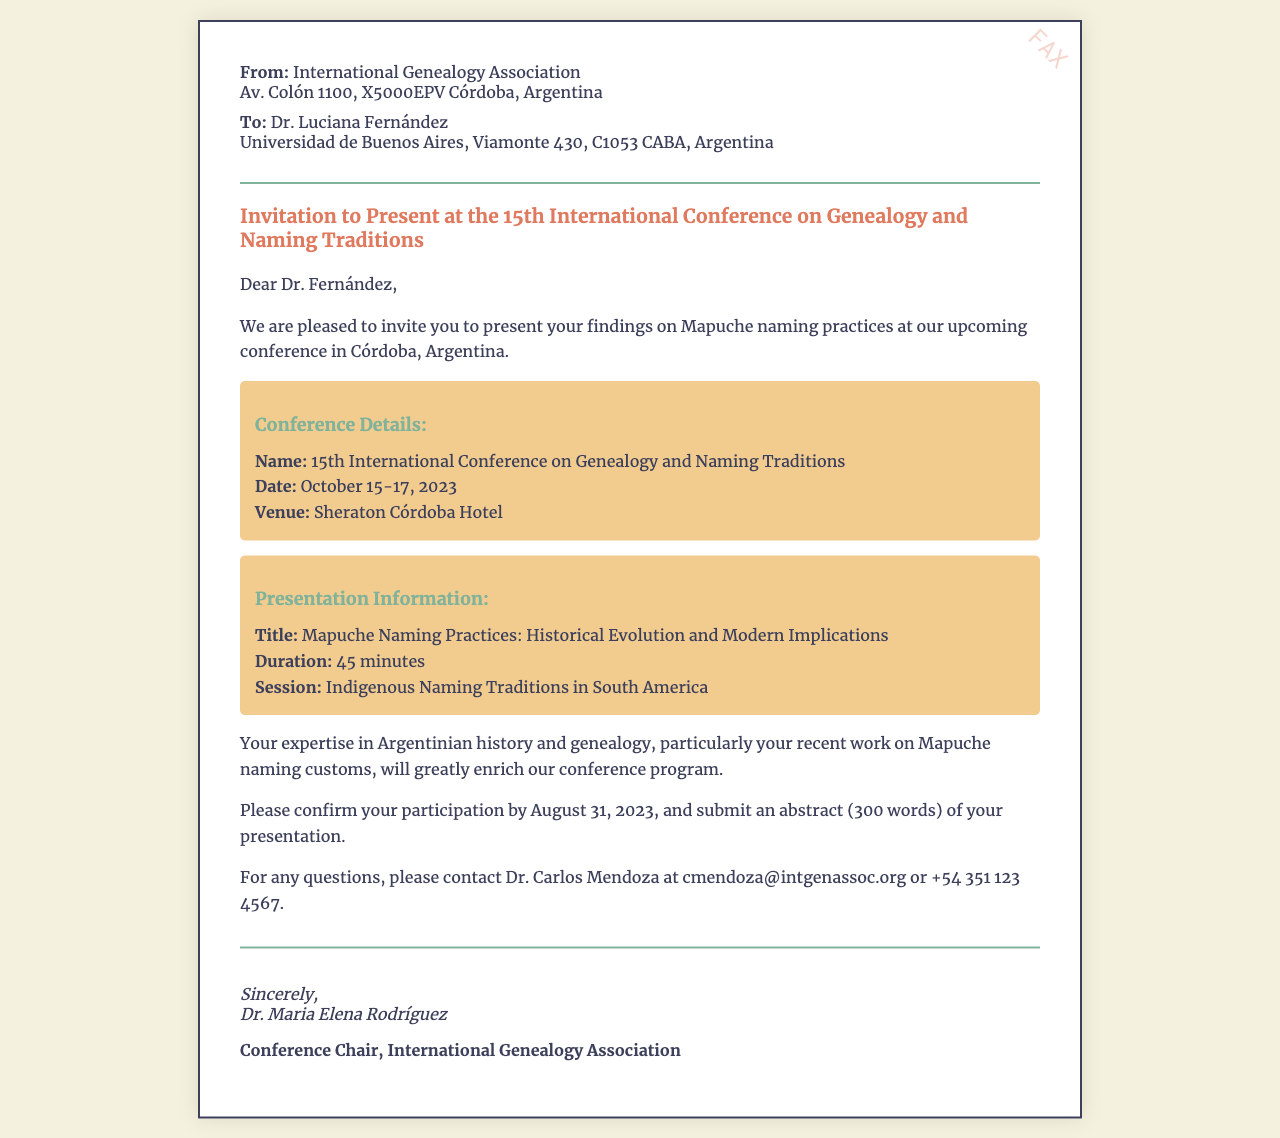What is the name of the conference? The name of the conference is stated in the subject line of the document, which is the 15th International Conference on Genealogy and Naming Traditions.
Answer: 15th International Conference on Genealogy and Naming Traditions What are the dates of the conference? The dates of the conference are provided in the conference details section, which states October 15-17, 2023.
Answer: October 15-17, 2023 Where is the conference venue? The venue is mentioned in the conference details section, which indicates that it will be held at the Sheraton Córdoba Hotel.
Answer: Sheraton Córdoba Hotel What is the presentation title? The title of the presentation is given in the presentation information section, which states, "Mapuche Naming Practices: Historical Evolution and Modern Implications."
Answer: Mapuche Naming Practices: Historical Evolution and Modern Implications Who should be contacted for questions? The document provides the contact information for Dr. Carlos Mendoza for any questions, indicated in the closing section of the body.
Answer: Dr. Carlos Mendoza What is the duration of the presentation? The duration of the presentation is mentioned in the presentation information, specifically stating that it is 45 minutes long.
Answer: 45 minutes What is the deadline for confirming participation? The document mentions the deadline for confirming participation is August 31, 2023.
Answer: August 31, 2023 What type of session will the presentation fall under? The session type is provided in the presentation information, indicating that it will be part of Indigenous Naming Traditions in South America.
Answer: Indigenous Naming Traditions in South America 